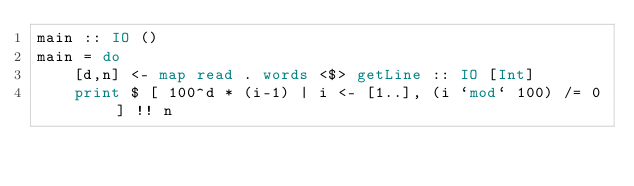Convert code to text. <code><loc_0><loc_0><loc_500><loc_500><_Haskell_>main :: IO ()
main = do
    [d,n] <- map read . words <$> getLine :: IO [Int]
    print $ [ 100^d * (i-1) | i <- [1..], (i `mod` 100) /= 0 ] !! n
</code> 